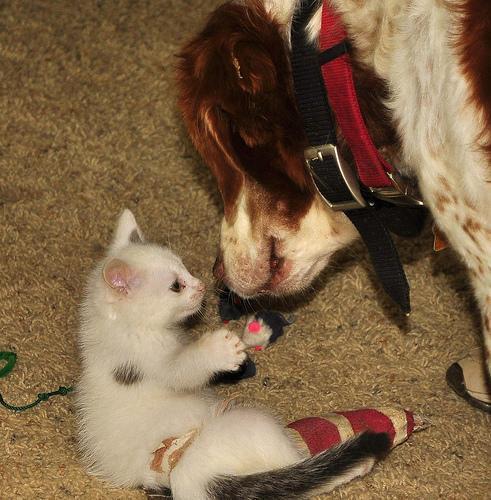How many pets?
Give a very brief answer. 2. 